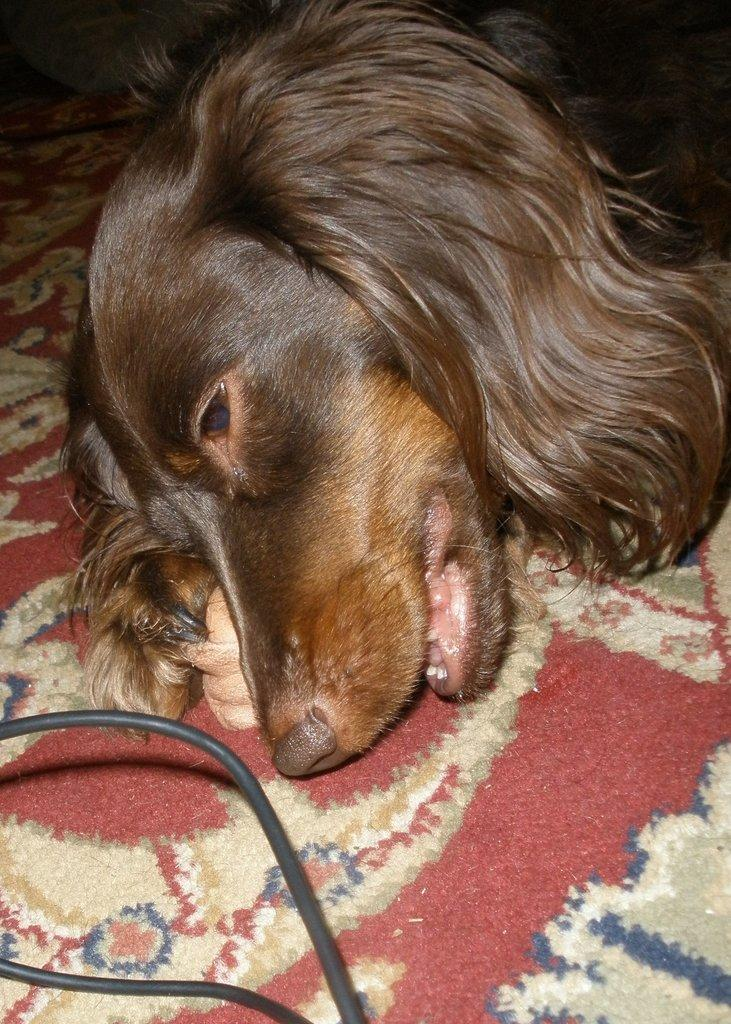What type of animal is in the image? There is a dog in the image. Where is the dog located in the image? The dog is on the floor. What else can be seen in the image besides the dog? There are wires visible in the image. What type of engine can be seen in the image? There is no engine present in the image; it features a dog on the floor and wires. What advice is the dog giving in the image? There is no indication in the image that the dog is giving any advice, as dogs do not communicate through verbal language. 